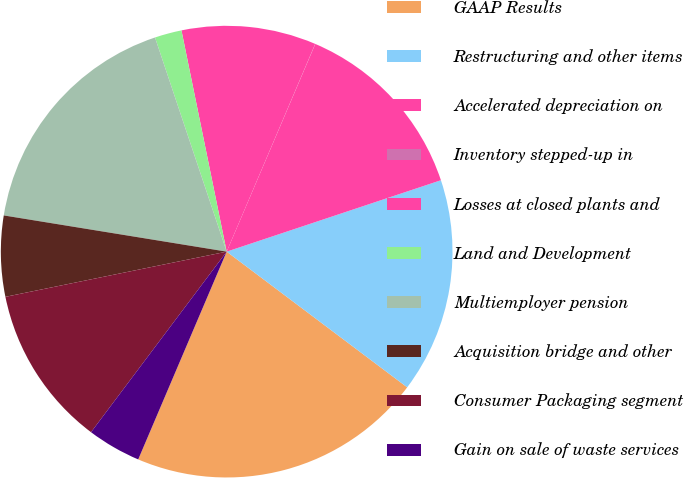<chart> <loc_0><loc_0><loc_500><loc_500><pie_chart><fcel>GAAP Results<fcel>Restructuring and other items<fcel>Accelerated depreciation on<fcel>Inventory stepped-up in<fcel>Losses at closed plants and<fcel>Land and Development<fcel>Multiemployer pension<fcel>Acquisition bridge and other<fcel>Consumer Packaging segment<fcel>Gain on sale of waste services<nl><fcel>21.15%<fcel>15.38%<fcel>13.46%<fcel>0.01%<fcel>9.62%<fcel>1.93%<fcel>17.3%<fcel>5.77%<fcel>11.54%<fcel>3.85%<nl></chart> 